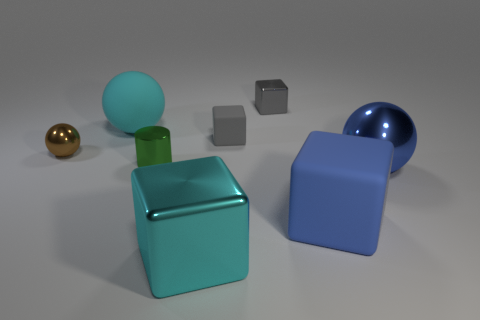Are there any other things that have the same shape as the tiny green thing?
Make the answer very short. No. Are there fewer metallic cylinders that are in front of the small gray metal cube than big cyan objects behind the large blue cube?
Your answer should be very brief. No. What number of big cyan objects are the same shape as the brown shiny object?
Offer a terse response. 1. There is a gray cube that is the same material as the green cylinder; what is its size?
Make the answer very short. Small. What is the color of the matte cube that is in front of the metal ball right of the small gray shiny thing?
Give a very brief answer. Blue. Is the shape of the tiny brown metal object the same as the big cyan object that is behind the blue shiny object?
Make the answer very short. Yes. What number of brown shiny objects have the same size as the gray rubber block?
Provide a succinct answer. 1. There is a large cyan thing that is the same shape as the small gray metallic thing; what is it made of?
Make the answer very short. Metal. There is a large object that is on the left side of the green shiny cylinder; is it the same color as the big metallic object on the left side of the big blue rubber object?
Provide a short and direct response. Yes. What shape is the metallic thing that is left of the big cyan rubber ball?
Ensure brevity in your answer.  Sphere. 